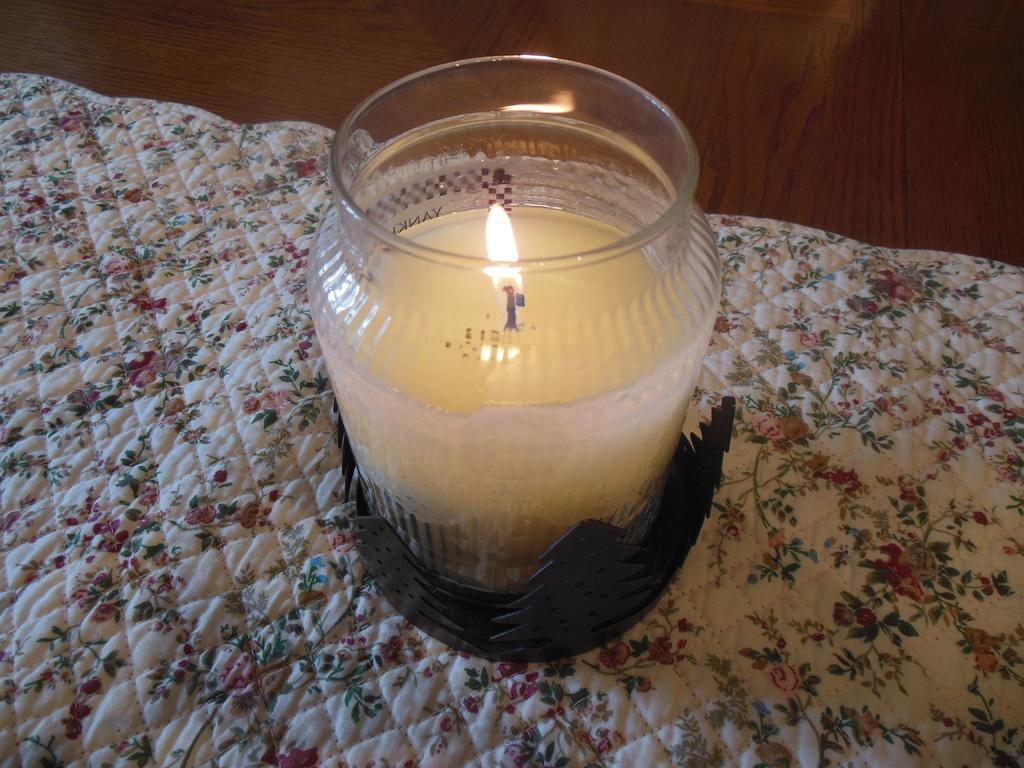Please provide a concise description of this image. In the image there is a candle kept in a jar and kept on a cloth. 